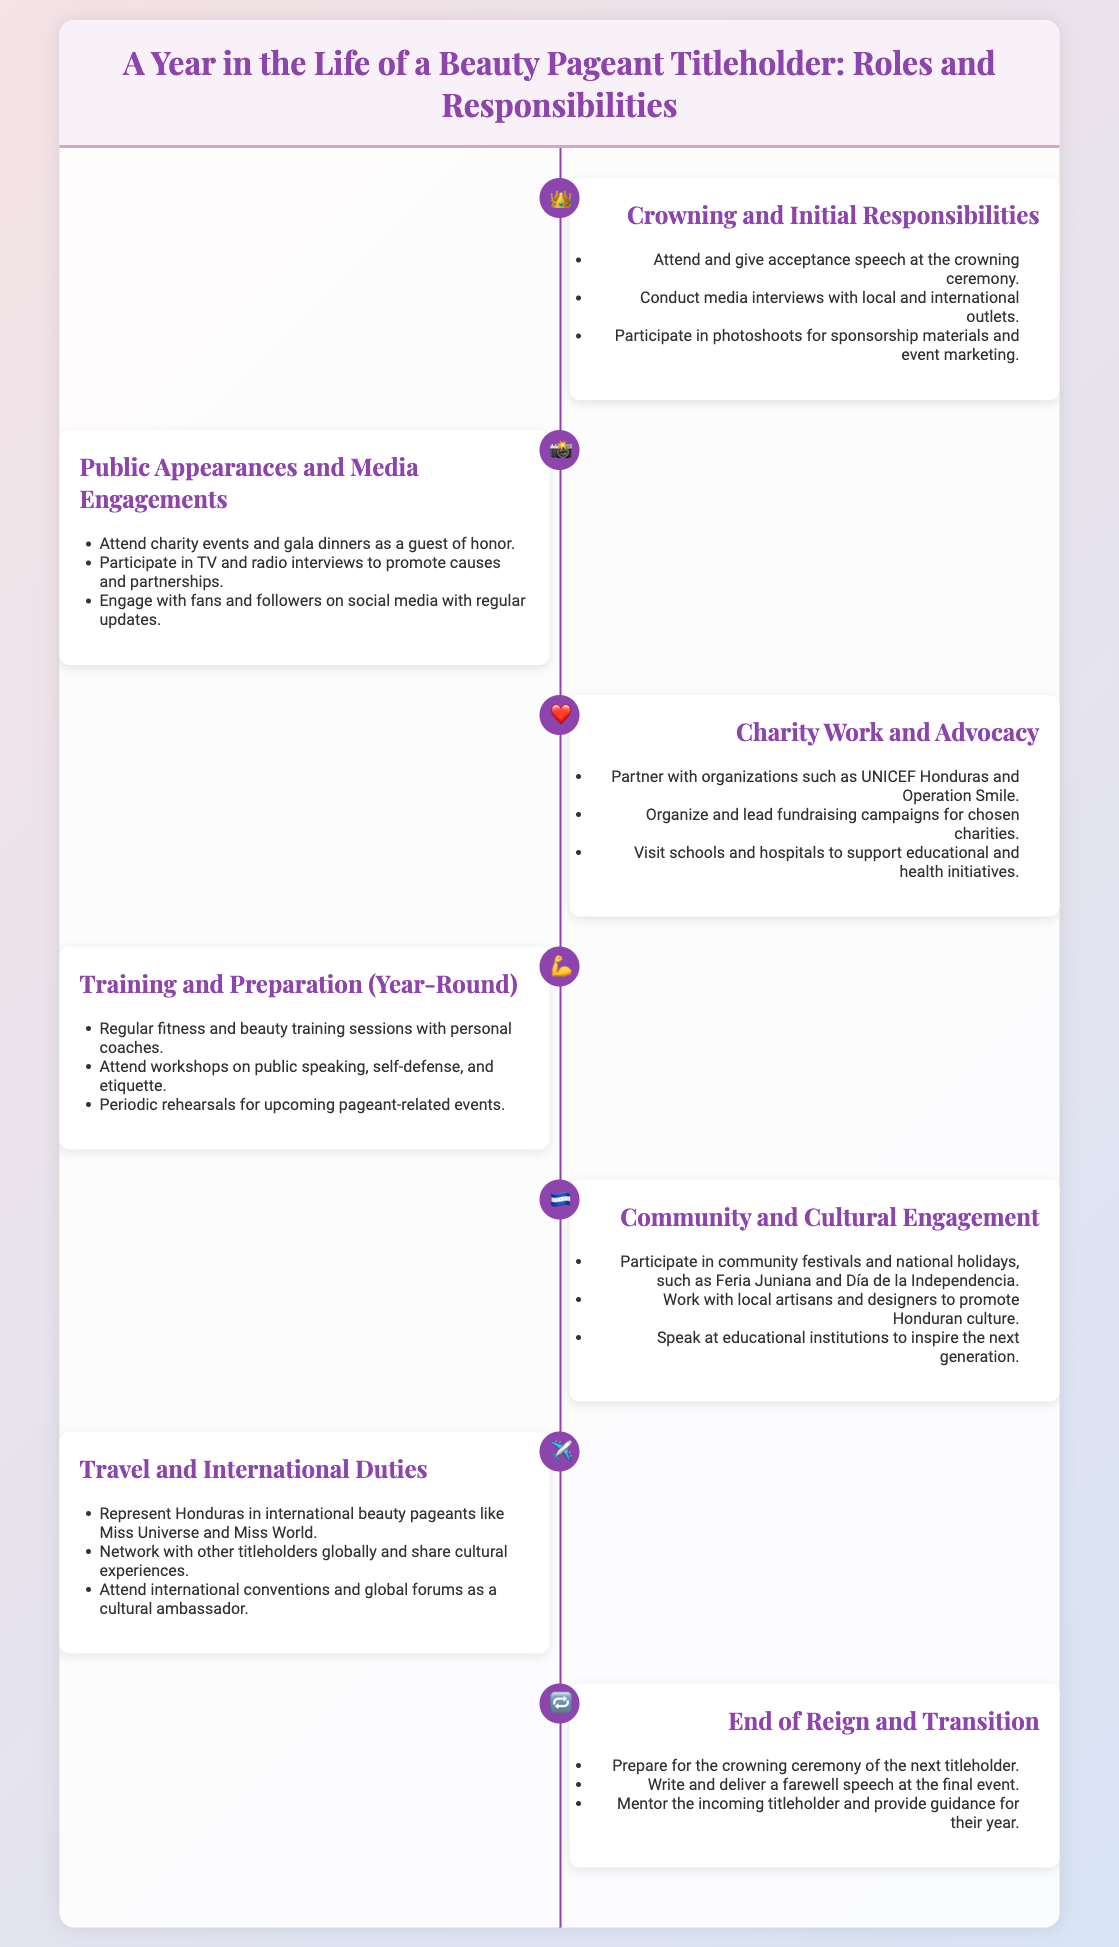What are the initial responsibilities of a titleholder? The document lists specific responsibilities right after crowning, including attending the ceremony, conducting media interviews, and participating in photoshoots.
Answer: Attend and give acceptance speech at the crowning ceremony How many types of activities are listed for public appearances? The document mentions three specific activities related to public appearances and media engagements.
Answer: Three Which organization is mentioned for charity partnerships? The titleholder is noted to partner with UNICEF Honduras for charity work and advocacy, per the document.
Answer: UNICEF Honduras What is the main focus of training and preparation throughout the year? The document outlines several training activities, emphasizing fitness and beauty training as central responsibilities of a titleholder.
Answer: Regular fitness and beauty training sessions with personal coaches What emblem is used for the community and cultural engagement section? The document uses a specific icon to represent community and cultural engagement, highlighting its significance in the titleholder's duties.
Answer: 🇭🇳 What does the titleholder do at the end of their reign? According to the document, the titleholder is responsible for preparing for the next crowning ceremony as a concluding duty.
Answer: Prepare for the crowning ceremony of the next titleholder How is the titleholder's international presence described? The document articulates the titleholder's international responsibilities, particularly through participation in beauty pageants like Miss Universe.
Answer: Represent Honduras in international beauty pageants like Miss Universe Which icon symbolizes training and preparation? The document features a specific emoji to signify the section dedicated to training and preparation for the titleholder's responsibilities.
Answer: 💪 